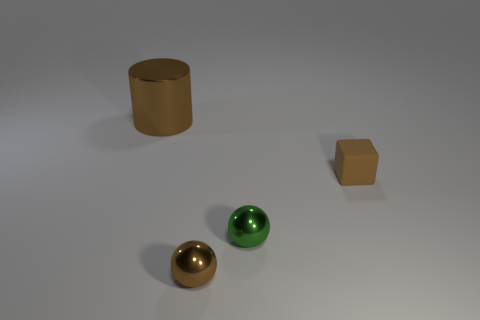There is a small brown thing in front of the small cube; what material is it?
Provide a short and direct response. Metal. Is the size of the matte cube the same as the cylinder?
Give a very brief answer. No. There is a brown thing that is to the right of the small ball that is on the left side of the green thing; what is its material?
Your answer should be very brief. Rubber. What number of rubber cubes have the same color as the large cylinder?
Keep it short and to the point. 1. Are there any other things that have the same material as the brown cube?
Your response must be concise. No. Are there fewer rubber things on the right side of the small matte cube than tiny matte things?
Offer a very short reply. Yes. What color is the metal ball on the right side of the brown object that is in front of the tiny green metallic object?
Offer a terse response. Green. What size is the brown thing left of the brown shiny thing to the right of the thing behind the brown matte cube?
Offer a terse response. Large. Are there fewer green things in front of the green thing than brown shiny cylinders to the left of the large brown metallic cylinder?
Your answer should be compact. No. What number of brown cubes are the same material as the cylinder?
Your response must be concise. 0. 